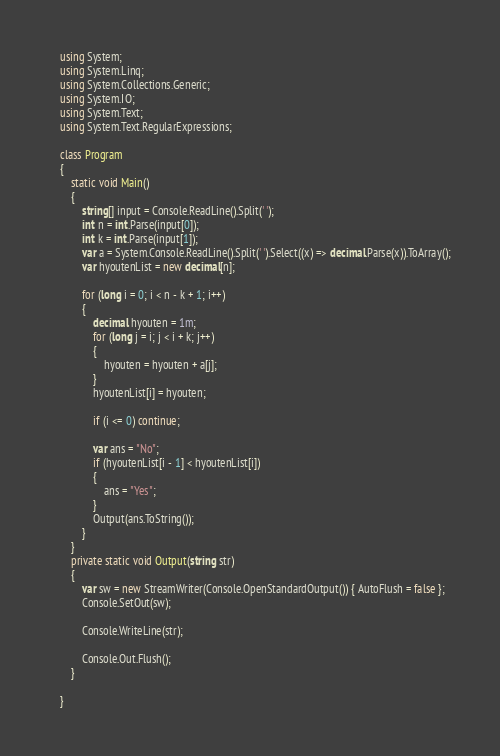<code> <loc_0><loc_0><loc_500><loc_500><_C#_>
    using System;
    using System.Linq;
    using System.Collections.Generic;
    using System.IO;
    using System.Text;
    using System.Text.RegularExpressions;

    class Program
    {
        static void Main()
        {
            string[] input = Console.ReadLine().Split(' ');
            int n = int.Parse(input[0]);
            int k = int.Parse(input[1]);
            var a = System.Console.ReadLine().Split(' ').Select((x) => decimal.Parse(x)).ToArray();
            var hyoutenList = new decimal[n];

            for (long i = 0; i < n - k + 1; i++)
            {
                decimal hyouten = 1m;
                for (long j = i; j < i + k; j++)
                {
                    hyouten = hyouten + a[j];
                }
                hyoutenList[i] = hyouten;

                if (i <= 0) continue;

                var ans = "No";
                if (hyoutenList[i - 1] < hyoutenList[i])
                {
                    ans = "Yes";
                }
                Output(ans.ToString());
            }
        }
        private static void Output(string str)
        {
            var sw = new StreamWriter(Console.OpenStandardOutput()) { AutoFlush = false };
            Console.SetOut(sw);

            Console.WriteLine(str);

            Console.Out.Flush();
        }

    }
</code> 